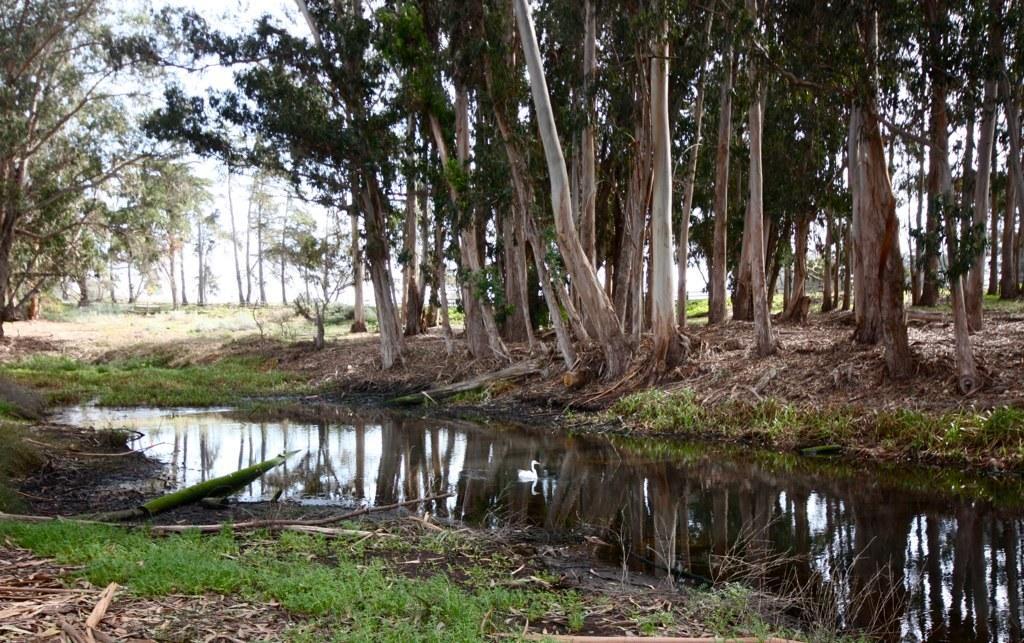Please provide a concise description of this image. In this picture there are trees. At the top there is sky. At the bottom there is a swan and there is a reflection of a swan on the water and there is grass. 